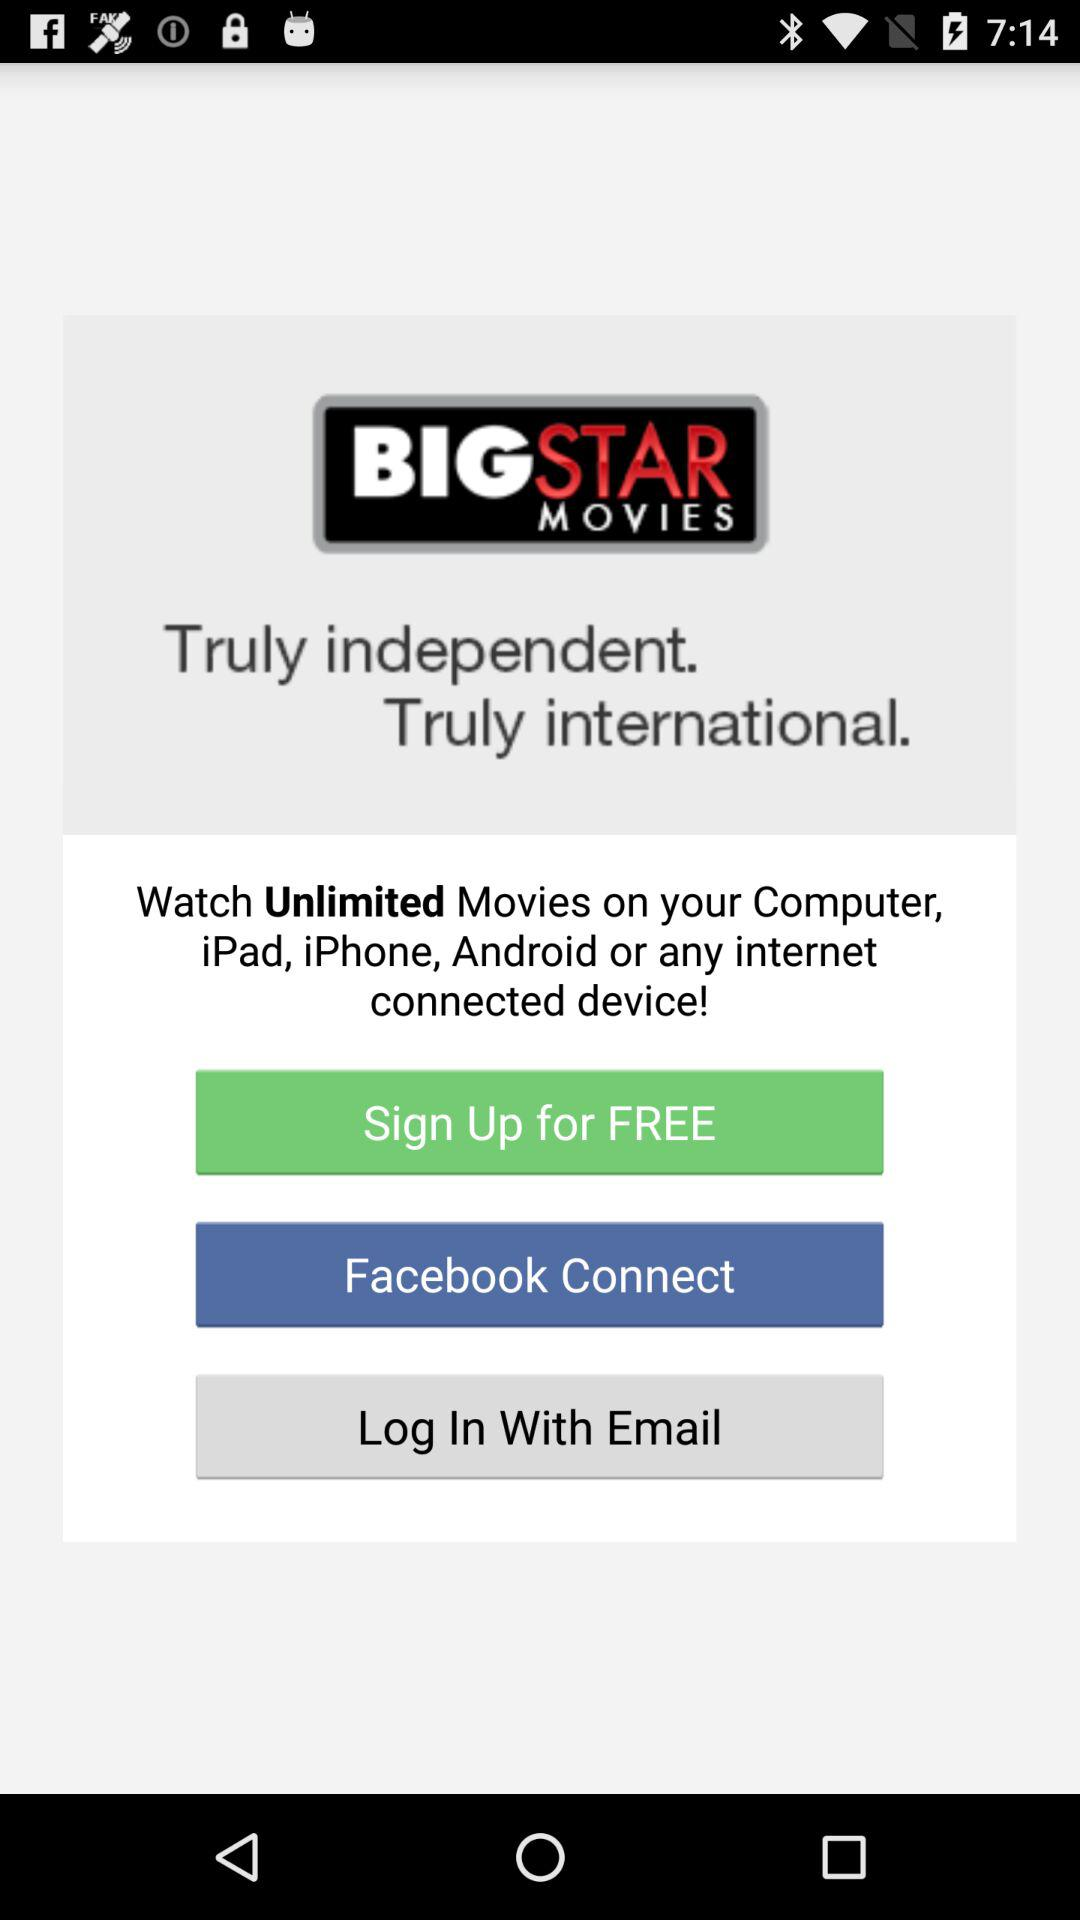What is the app name? The app name is "BIGSTAR MOVIES". 